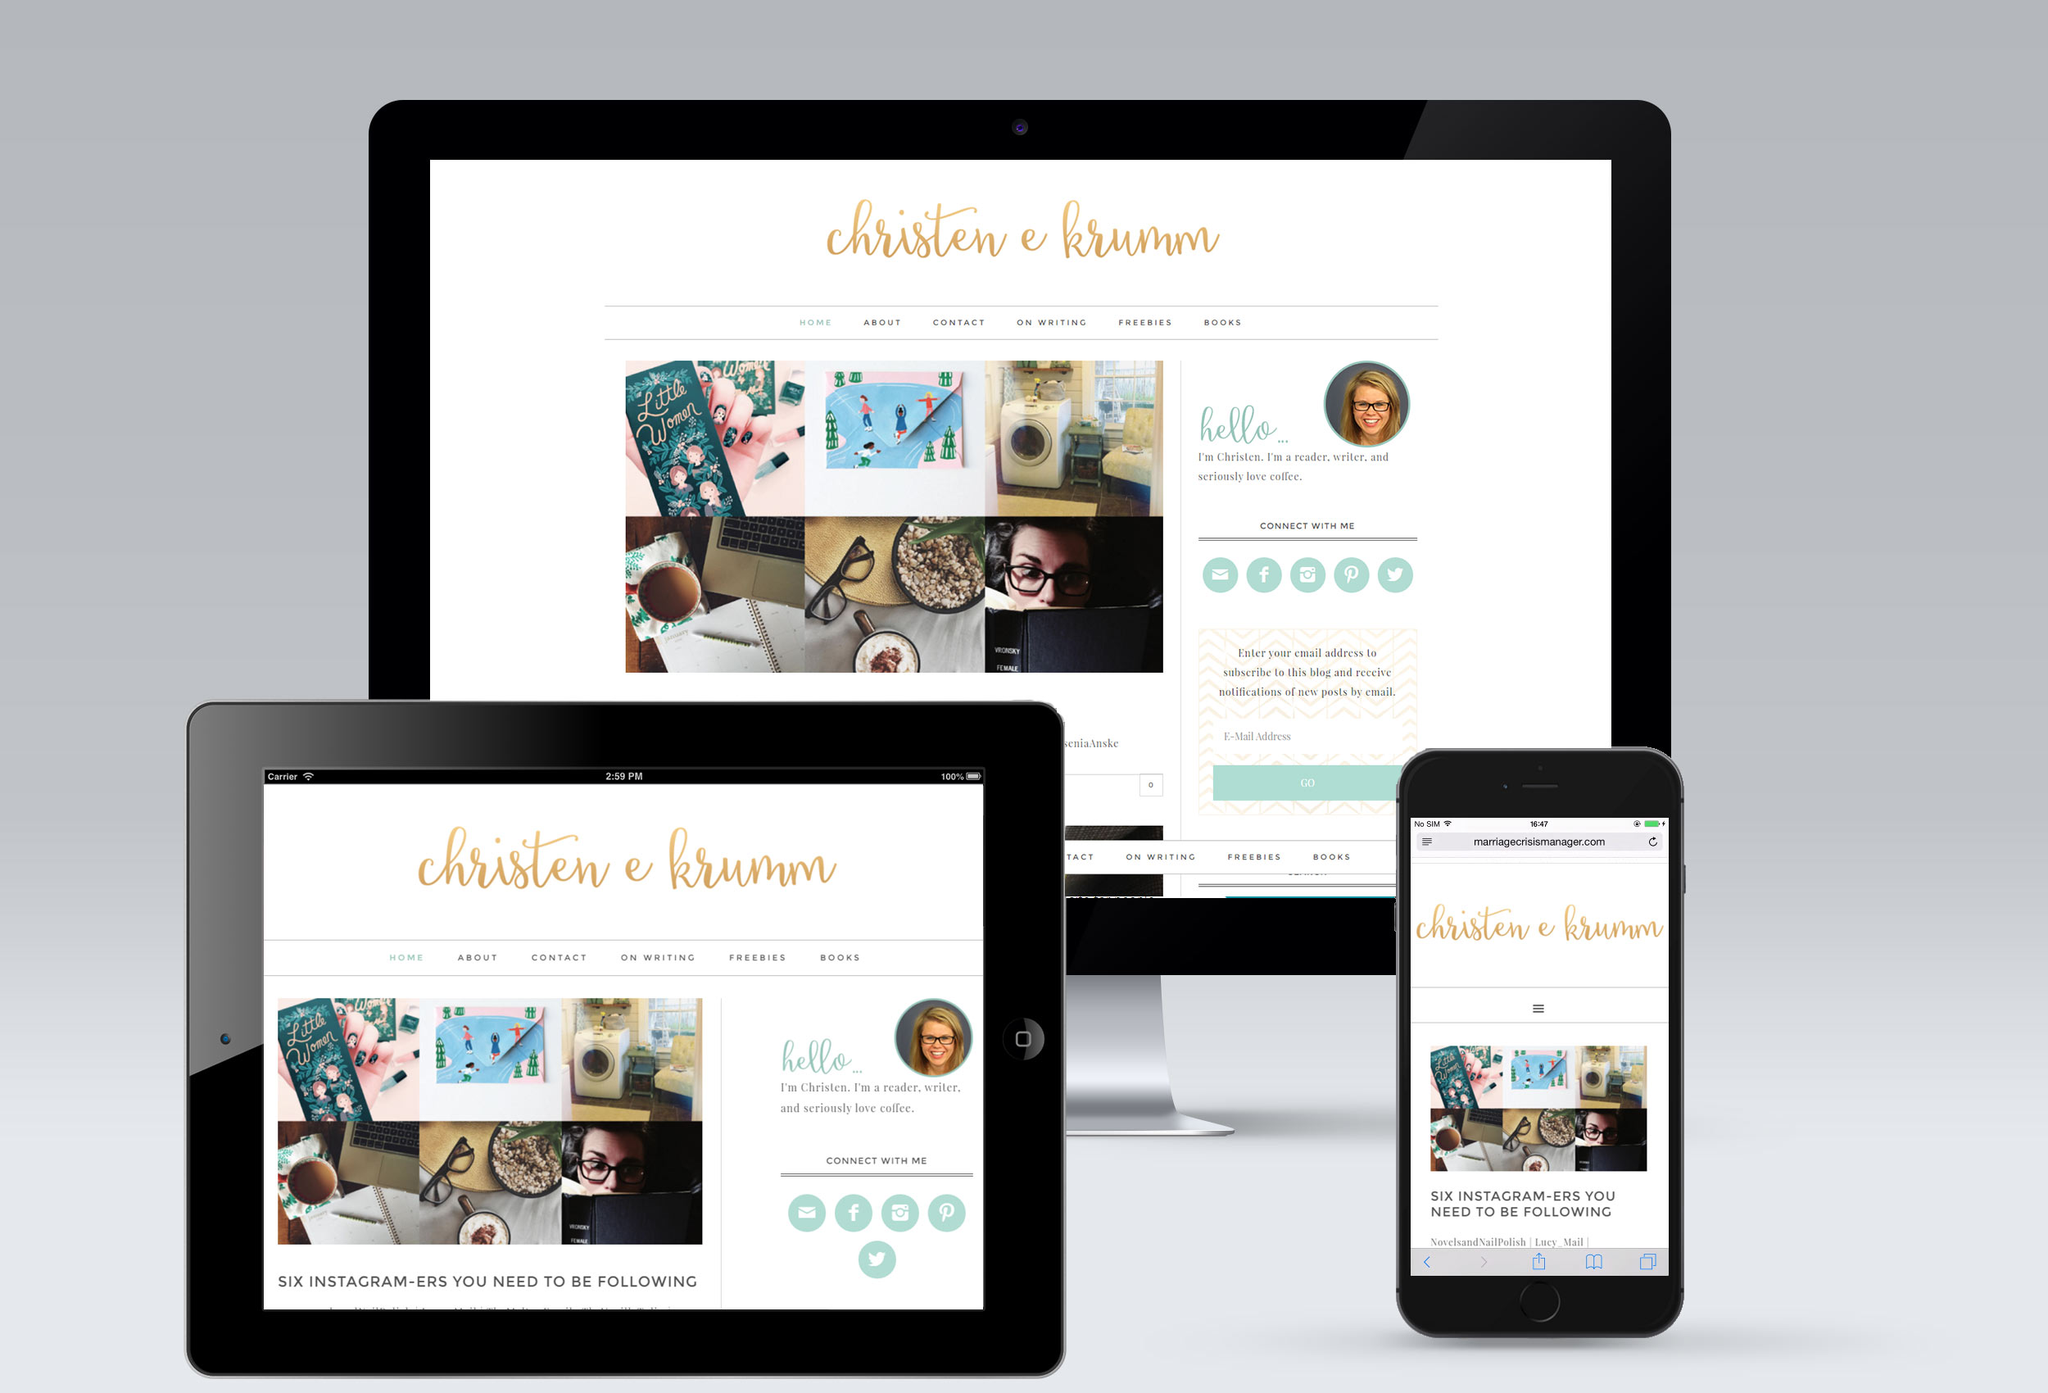How do the images featured on the website relate to the content topics covered? The images showcase a desk setup with a laptop, notepad, coffee cup, and personal items like framed pictures and a pen holder, which relate to topics of personal productivity, lifestyle, and modern working environments. These visuals complement articles or blog posts on topics such as creativity in workspaces, importance of organized personal space, and tips for effective social media presence. Each image reinforces the website’s themes by portraying a realistic and relatable scene that resonates with the audience's daily life and interests. 